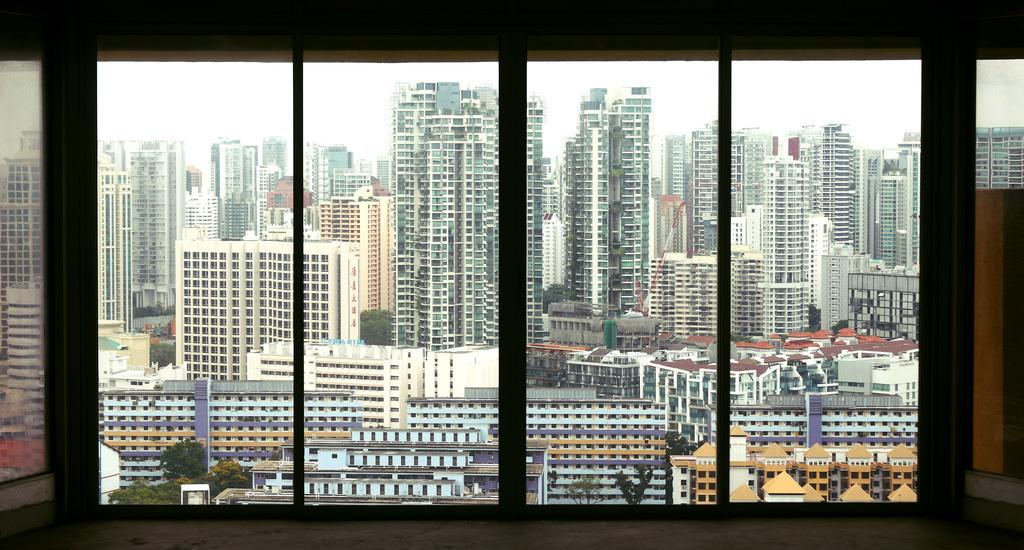What type of structures can be seen in the image? There is a group of buildings in the image. What other natural elements are present in the image? There are trees in the image. What is visible in the background of the image? The sky is visible in the image. What type of machinery can be seen in the image? There is a crane in the image. What part of a building is visible in the foreground of the image? There is a window in the foreground of the image. Can you tell me how many cattle are grazing near the buildings in the image? There are no cattle present in the image; it features a group of buildings, trees, the sky, a crane, and a window. What type of basket is hanging from the window in the image? There is no basket hanging from the window in the image; only the window is present. 